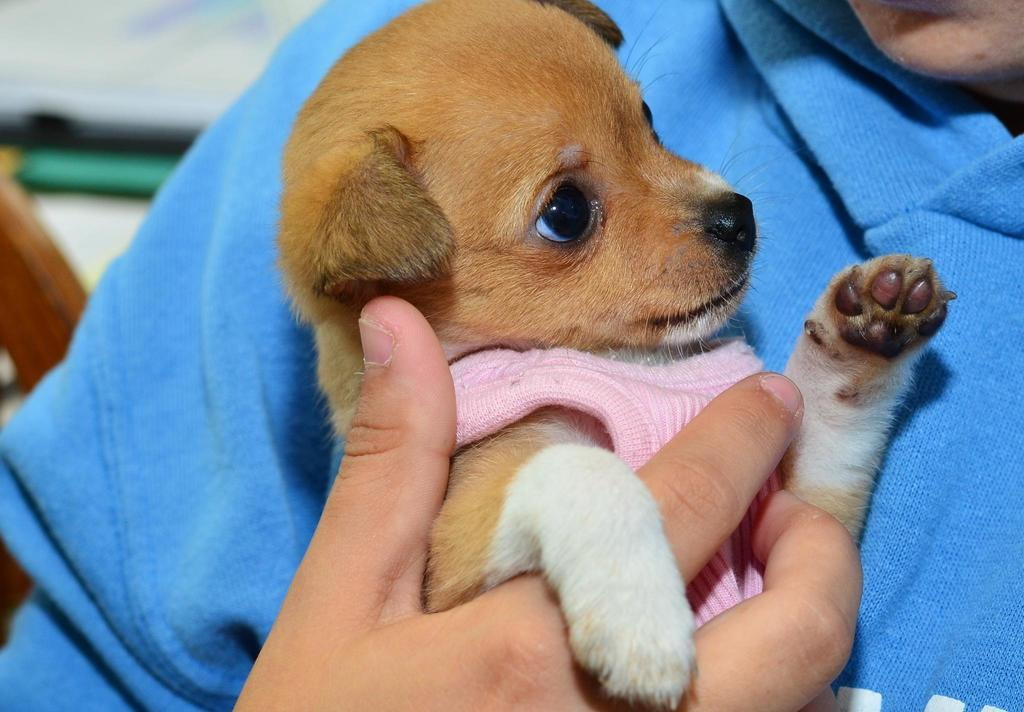What is the main subject of the image? There is a person in the image. What is the person wearing? The person is wearing clothes. What is the person holding in the image? The person is holding a dog. Can you describe the dog's appearance? The dog is white and pale brown in color. What can be observed about the background of the image? The background of the image is blurred. What size of hook is being used to hold the basket in the image? There is no hook or basket present in the image. 